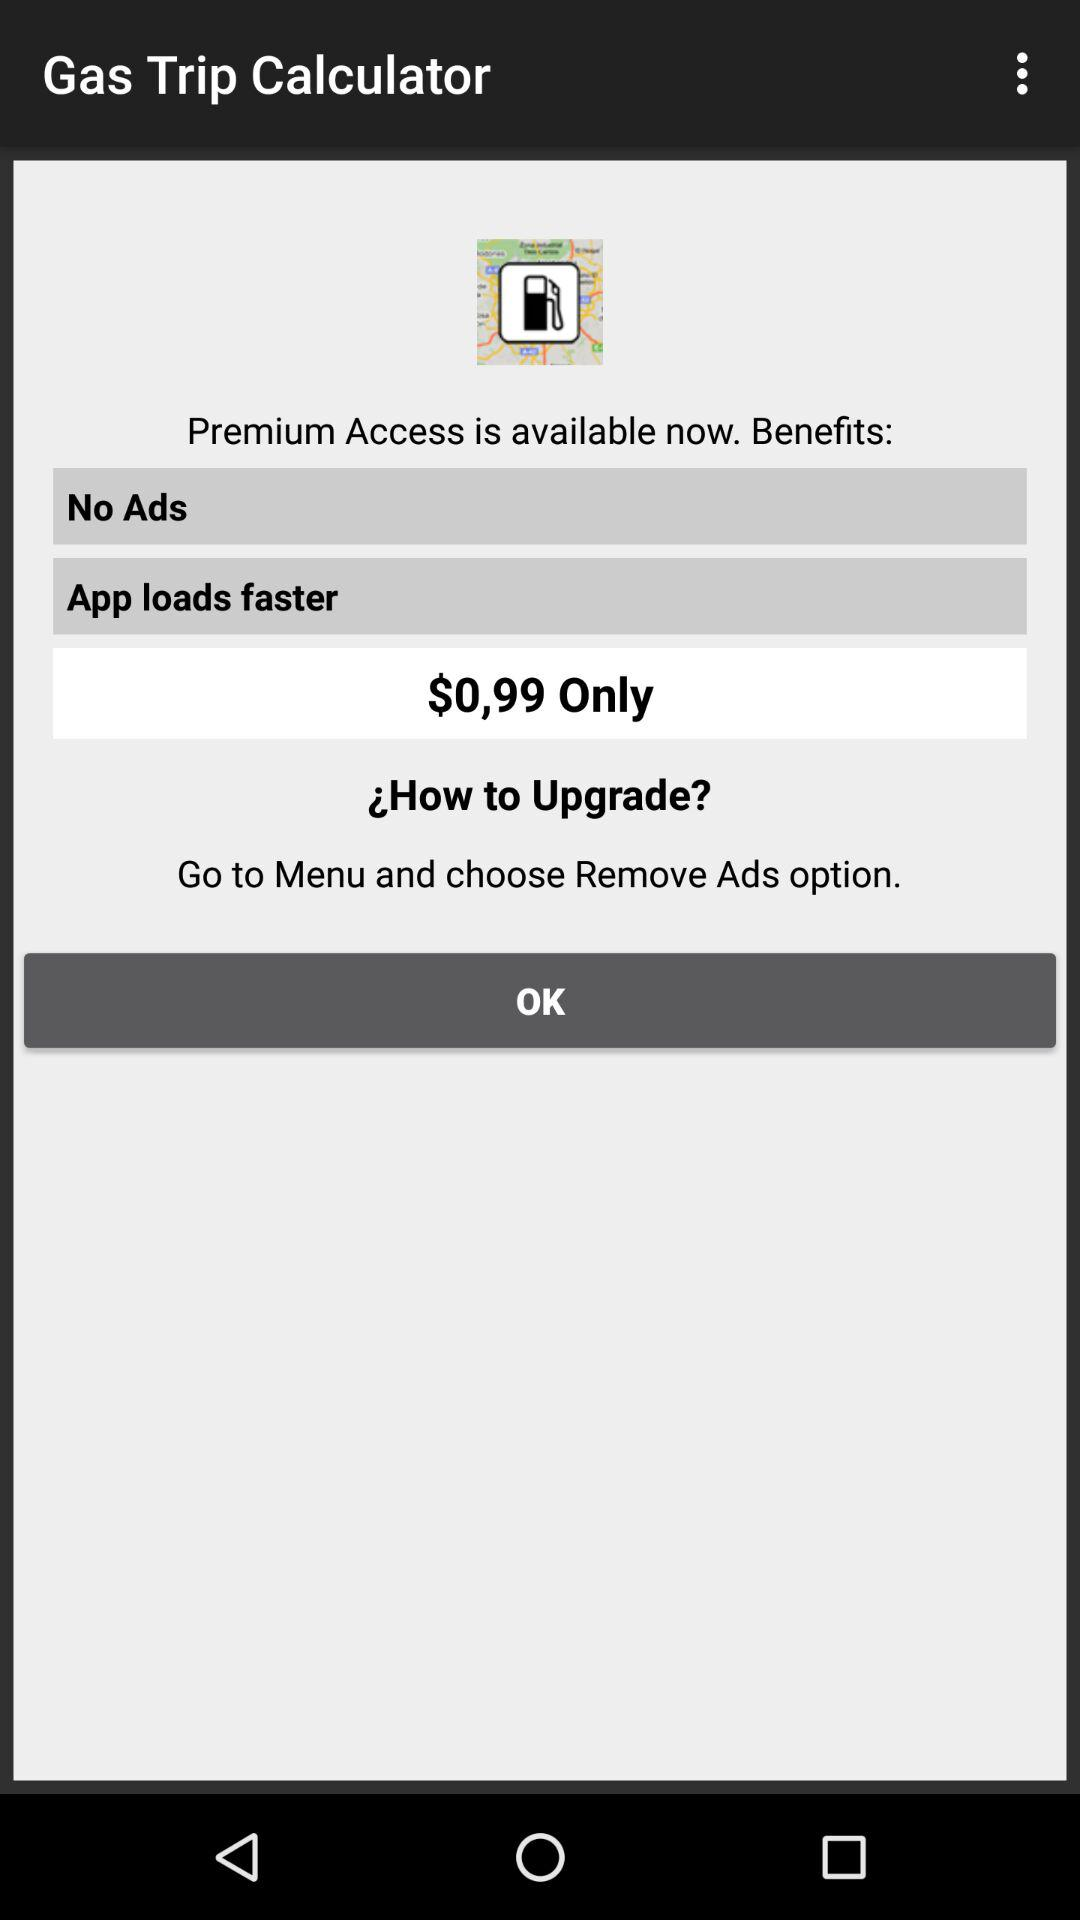What is the app name? The app name is "Gas Trip Calculator". 